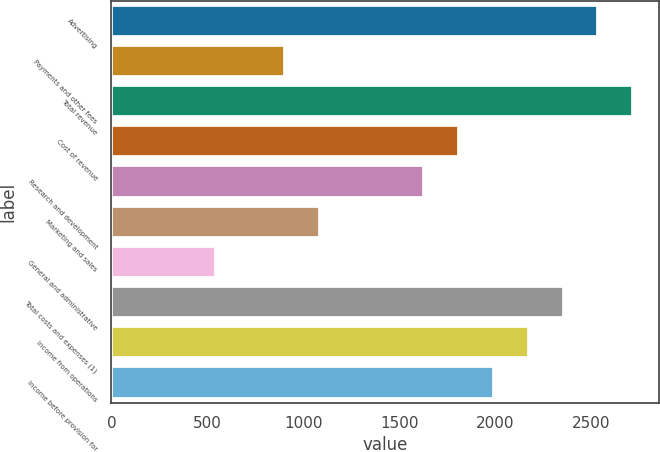Convert chart. <chart><loc_0><loc_0><loc_500><loc_500><bar_chart><fcel>Advertising<fcel>Payments and other fees<fcel>Total revenue<fcel>Cost of revenue<fcel>Research and development<fcel>Marketing and sales<fcel>General and administrative<fcel>Total costs and expenses (1)<fcel>Income from operations<fcel>Income before provision for<nl><fcel>2538.19<fcel>906.58<fcel>2719.48<fcel>1813.03<fcel>1631.74<fcel>1087.87<fcel>544<fcel>2356.9<fcel>2175.61<fcel>1994.32<nl></chart> 